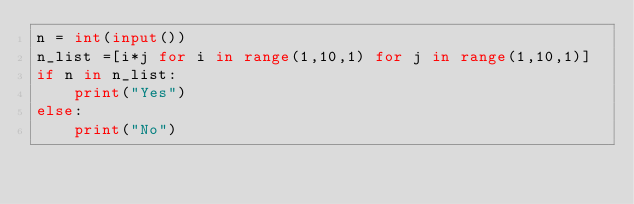<code> <loc_0><loc_0><loc_500><loc_500><_Python_>n = int(input())
n_list =[i*j for i in range(1,10,1) for j in range(1,10,1)]
if n in n_list:
    print("Yes")
else:
    print("No")</code> 